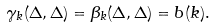Convert formula to latex. <formula><loc_0><loc_0><loc_500><loc_500>\gamma _ { k } ( \Delta , \Delta ) = \beta _ { k } ( \Delta , \Delta ) = b ( k ) .</formula> 